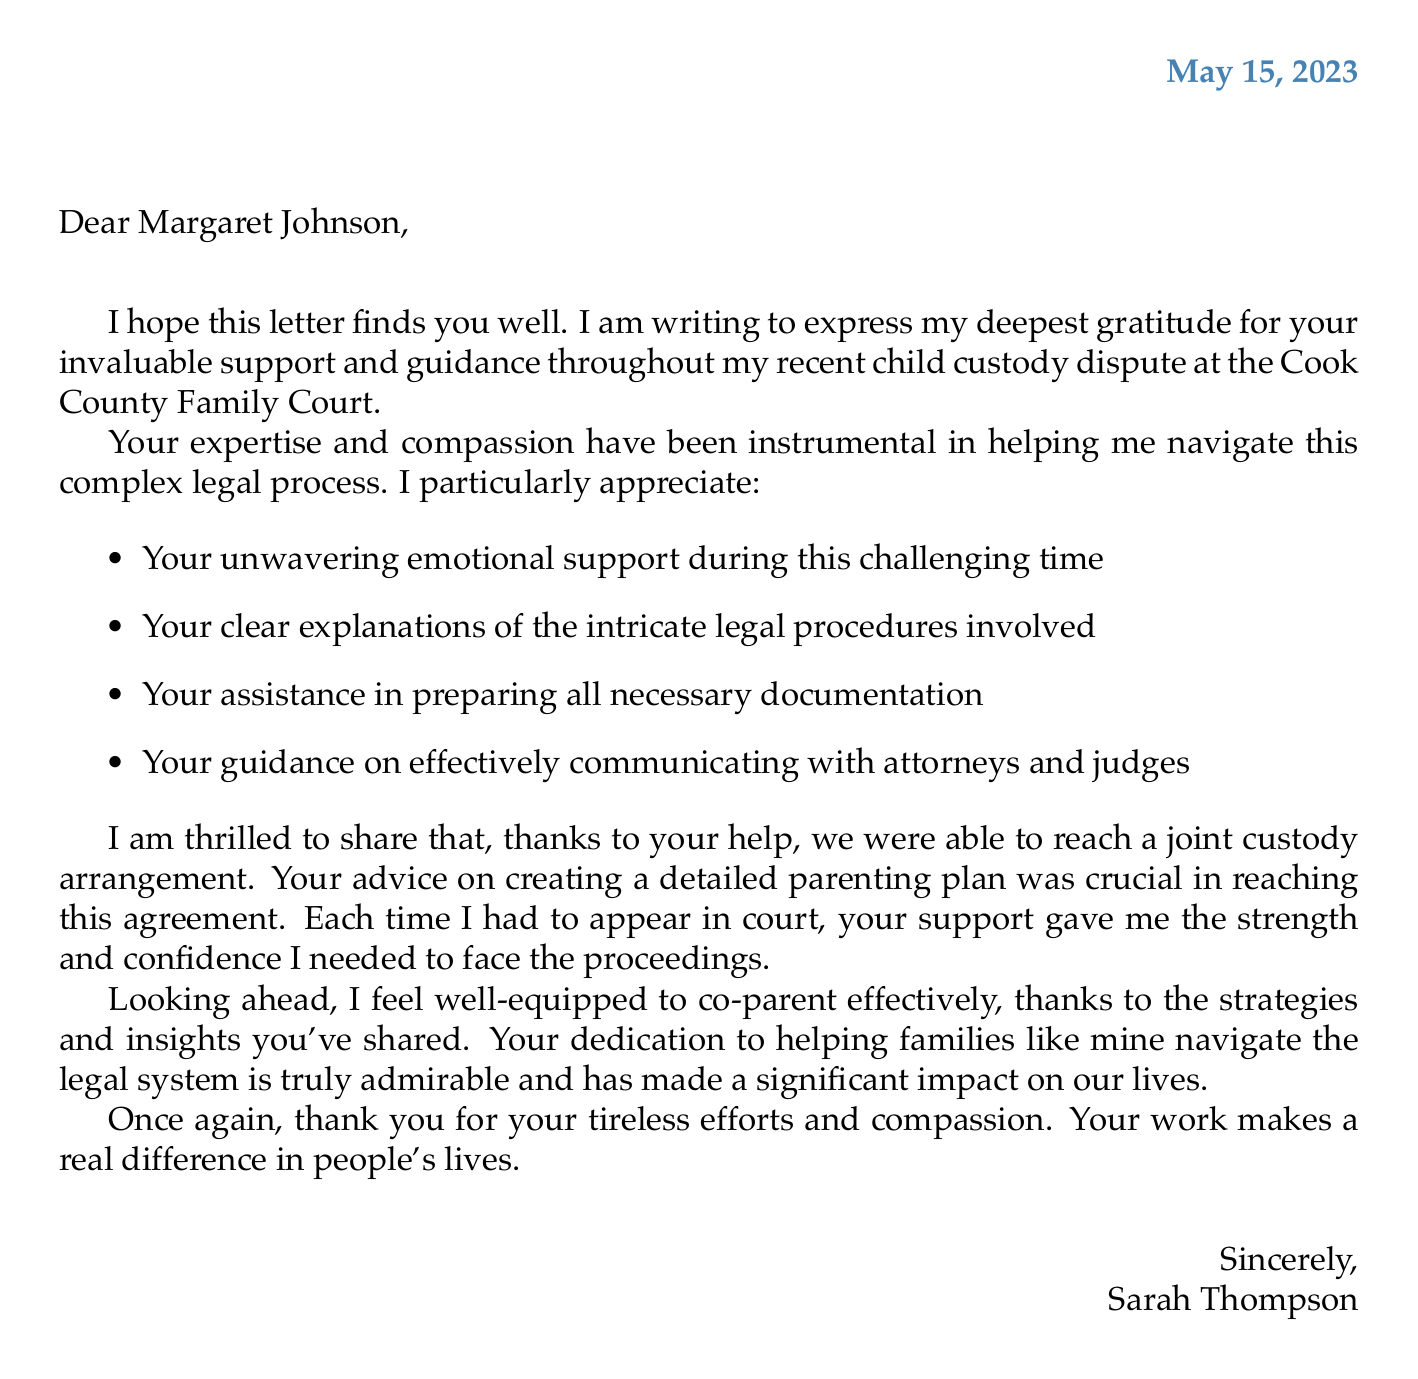What is the date of the letter? The date of the letter is found in the header section.
Answer: May 15, 2023 Who is the client expressing gratitude? The client's name is stated at the beginning of the letter.
Answer: Sarah Thompson What legal case is mentioned? The legal case is highlighted in the context of the client's situation.
Answer: Child custody dispute What court was involved in the process? The court's name is specified in the letter.
Answer: Cook County Family Court What key outcome does the client mention? The outcome is summarized in a positive statement related to custody.
Answer: Joint custody arrangement What emotional impact did the support have on the client? This information is conveyed through the client's personal reflections in the letter.
Answer: Strength to face each court appearance with confidence What specific advice was crucial for reaching the agreement? The letter includes a specific example of assistance provided.
Answer: Creating a detailed parenting plan Who provided the guidance in navigating the legal system? The provider of guidance is mentioned at the beginning of the letter.
Answer: Margaret Johnson What does the client feel equipped to do for the future? The future outlook is expressed in the letter regarding the client's capabilities.
Answer: Co-parent effectively 